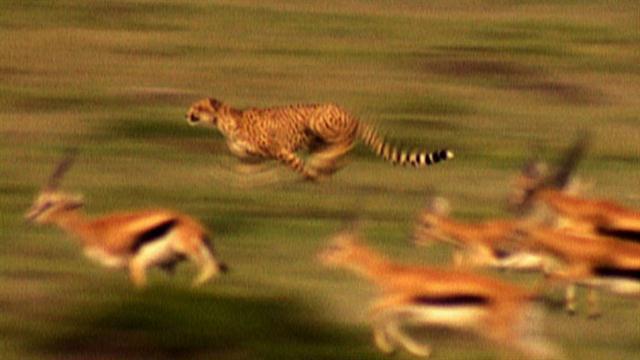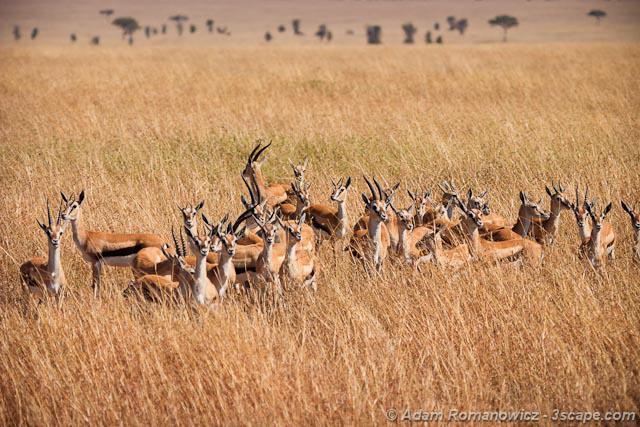The first image is the image on the left, the second image is the image on the right. Examine the images to the left and right. Is the description "At least one of the images contains a single large cat chasing a single animal with no other animals present." accurate? Answer yes or no. No. The first image is the image on the left, the second image is the image on the right. For the images displayed, is the sentence "In the left image there is one cheetah and it is running towards the left." factually correct? Answer yes or no. Yes. 